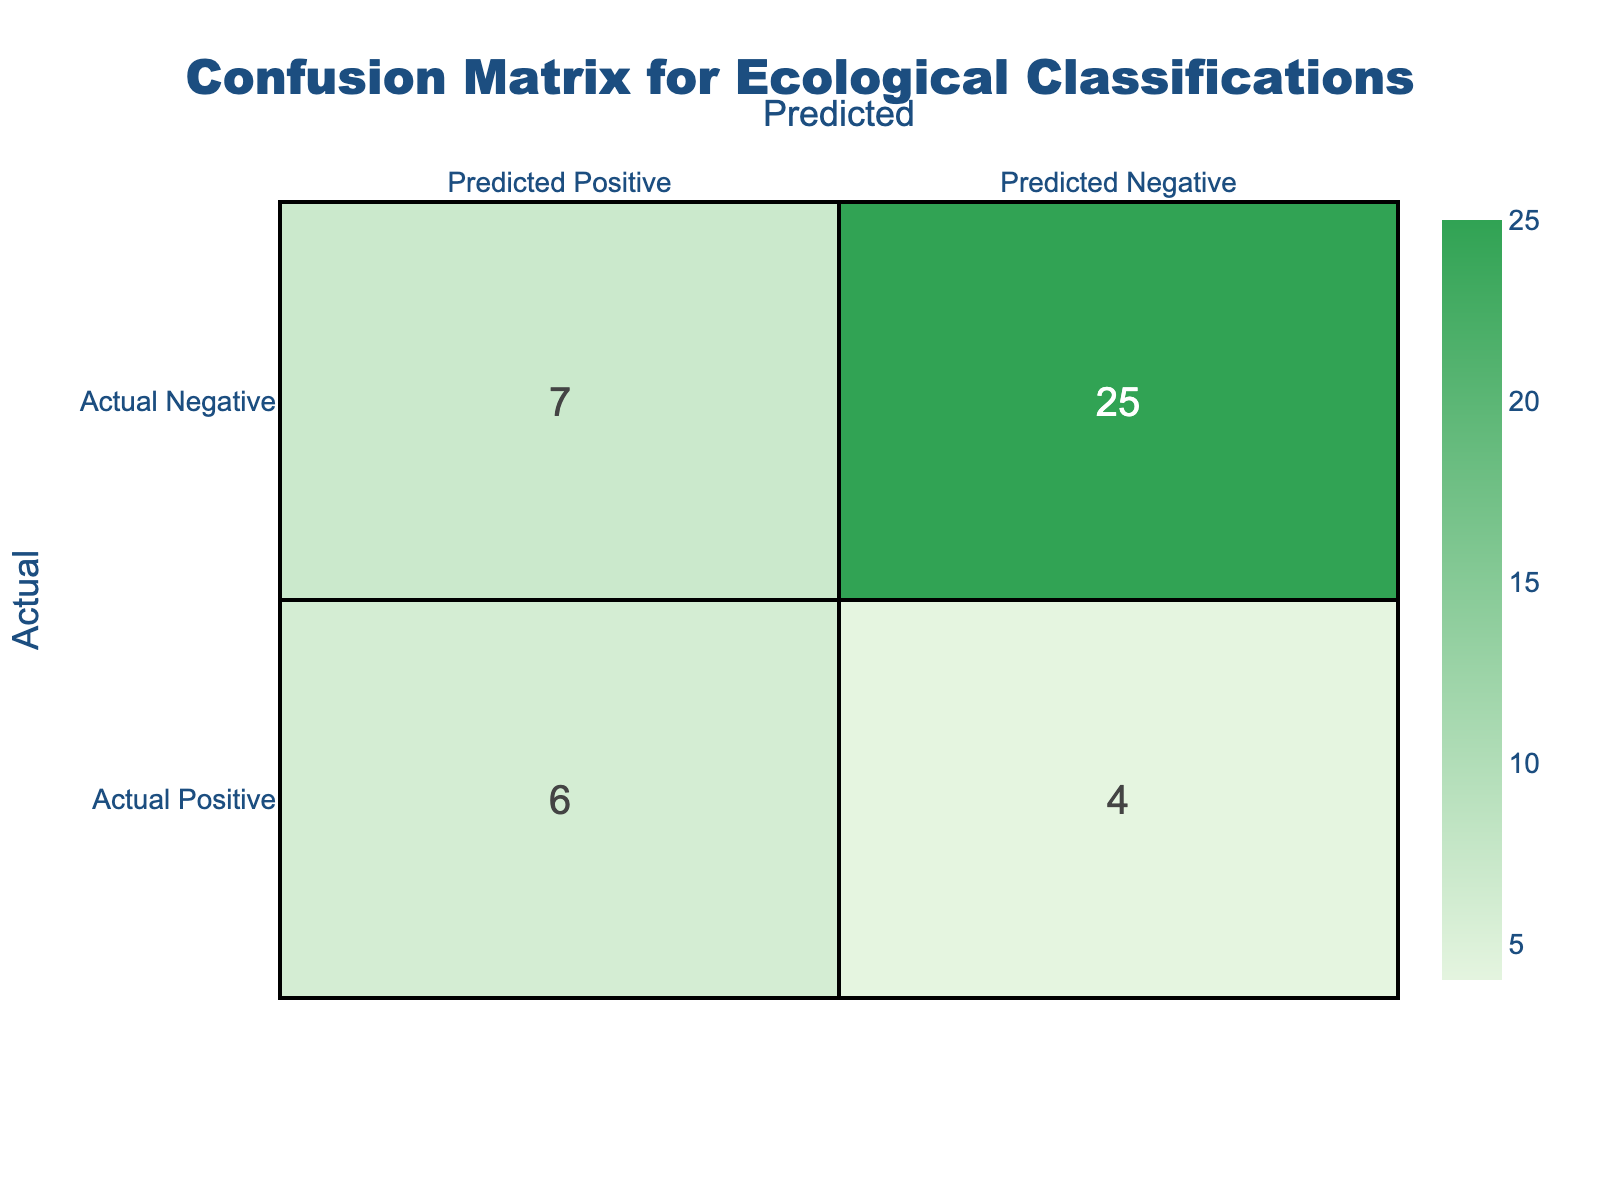What is the total number of true positives (TP) recorded in the confusion matrix? To find the total true positives, add up the TP values from each row in the table: 1 (Forest) + 1 (Wetland) + 0 (Grassland) + 1 (Desert) + 0 (Urban) + 1 (Marine) + 1 (Forest) + 0 (Grassland) + 1 (Wetland) + 0 (Urban) = 5.
Answer: 5 How many false positives (FP) are associated with the Urban classification? The table shows that in the Urban classification, there are 1 FP for Petromyzon marinus and 1 FP for Turdus merula, thus the total is 1 + 1 = 2.
Answer: 2 What is the total count of true negatives (TN) across all classifications? To calculate total true negatives, add the TN values for each row: 3 (Forest) + 2 (Wetland) + 2 (Grassland) + 3 (Desert) + 2 (Urban) + 4 (Marine) + 3 (Forest) + 2 (Grassland) + 2 (Wetland) + 2 (Urban) = 24.
Answer: 24 Is there any instance of false negatives (FN) in the Desert classification? The Desert classification has an FN value of 0, meaning there are no false negatives recorded for this classification.
Answer: No Which ecological classification has the highest number of actual negatives (TN)? The maximum TN value among all classifications is 4, which is found in the Marine classification, indicating it has the highest number of actual negatives.
Answer: Marine Calculate the average true positives (TP) across all classifications. The total number of true positives is 5 and there are 10 classifications total. Therefore, the average TP is 5 / 10 = 0.5.
Answer: 0.5 Which classification has the highest overall accuracy based on the confusion matrix values? To calculate accuracy for each classification, we consider the formula: (TP + TN) / (TP + TN + FP + FN). For the Marine classification, (1 + 4) / (1 + 4 + 0 + 0) = 1, which is the highest accuracy.
Answer: Marine If we combine all false negatives (FN), what is the total count? The total FN can be summed from the table: 1 (Forest) + 0 (Wetland) + 1 (Grassland) + 0 (Desert) + 2 (Urban) + 0 (Marine) + 1 (Forest) + 1 (Grassland) + 0 (Wetland) + 1 (Urban) = 7.
Answer: 7 How does the total number of false positives (FP) compare to false negatives (FN)? Total FP is calculated as 0 (Forest) + 0 (Wetland) + 1 (Grassland) + 0 (Desert) + 1 (Urban) + 0 (Marine) + 0 (Forest) + 1 (Grassland) + 0 (Wetland) + 1 (Urban) = 4 and total FN is 7. Therefore, FP < FN.
Answer: False positives are fewer than false negatives 